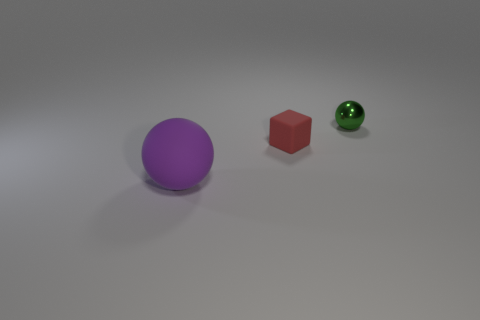Add 1 small matte balls. How many objects exist? 4 Subtract all purple spheres. How many spheres are left? 1 Subtract all balls. How many objects are left? 1 Subtract 2 spheres. How many spheres are left? 0 Add 2 big purple matte balls. How many big purple matte balls are left? 3 Add 3 big blocks. How many big blocks exist? 3 Subtract 0 blue cubes. How many objects are left? 3 Subtract all cyan spheres. Subtract all blue cubes. How many spheres are left? 2 Subtract all brown balls. How many purple cubes are left? 0 Subtract all small red things. Subtract all small spheres. How many objects are left? 1 